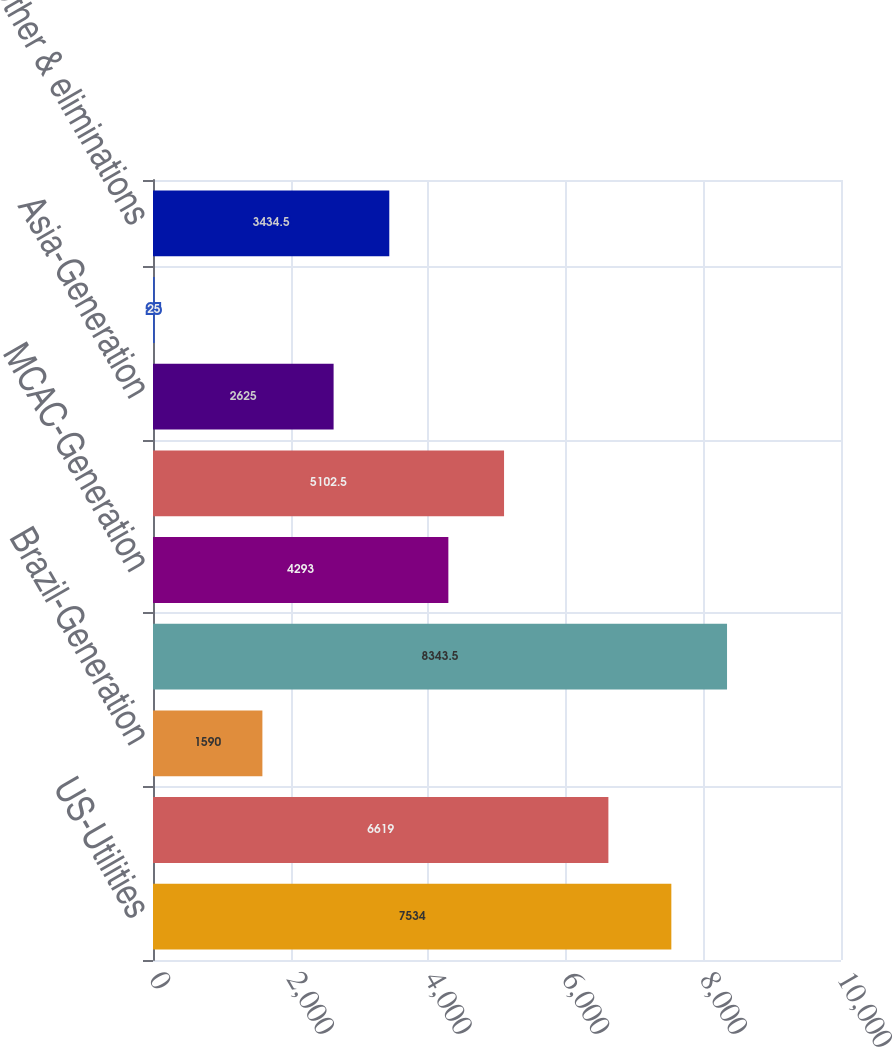<chart> <loc_0><loc_0><loc_500><loc_500><bar_chart><fcel>US-Utilities<fcel>Andes-Generation<fcel>Brazil-Generation<fcel>Brazil-Utilities<fcel>MCAC-Generation<fcel>EMEA-Generation<fcel>Asia-Generation<fcel>Discontinued businesses<fcel>Corp and Other & eliminations<nl><fcel>7534<fcel>6619<fcel>1590<fcel>8343.5<fcel>4293<fcel>5102.5<fcel>2625<fcel>25<fcel>3434.5<nl></chart> 